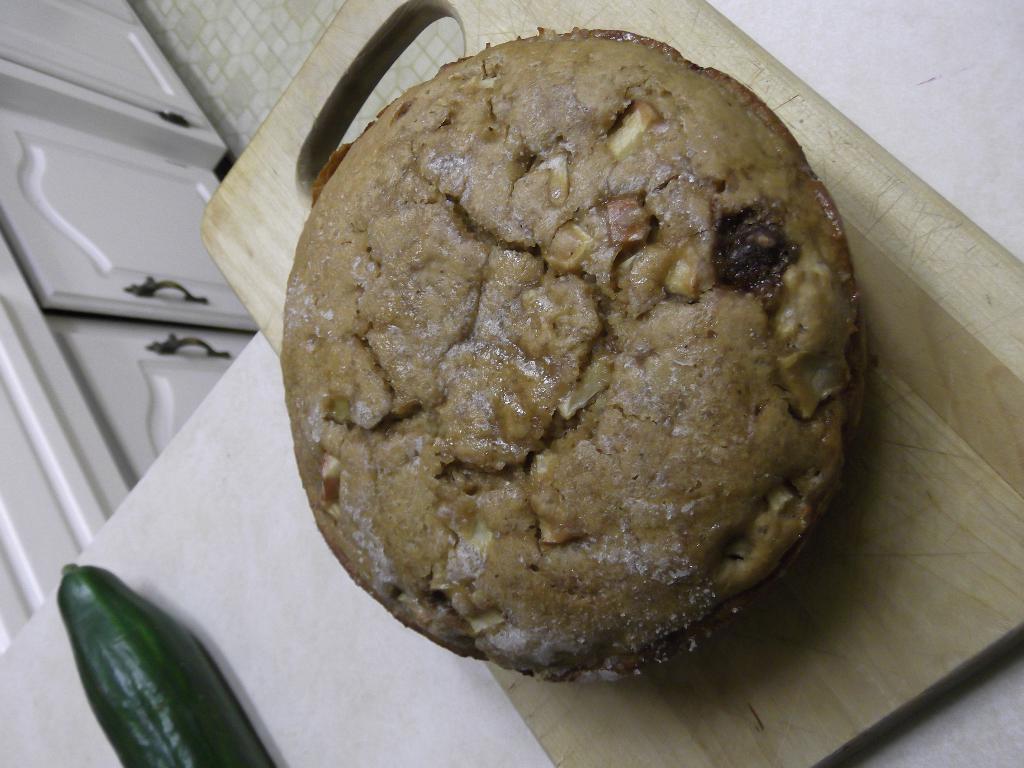How would you summarize this image in a sentence or two? In this picture we can see a cake on a chopper board, vegetable and these are placed on a white platform and in the background we can see cupboards. 